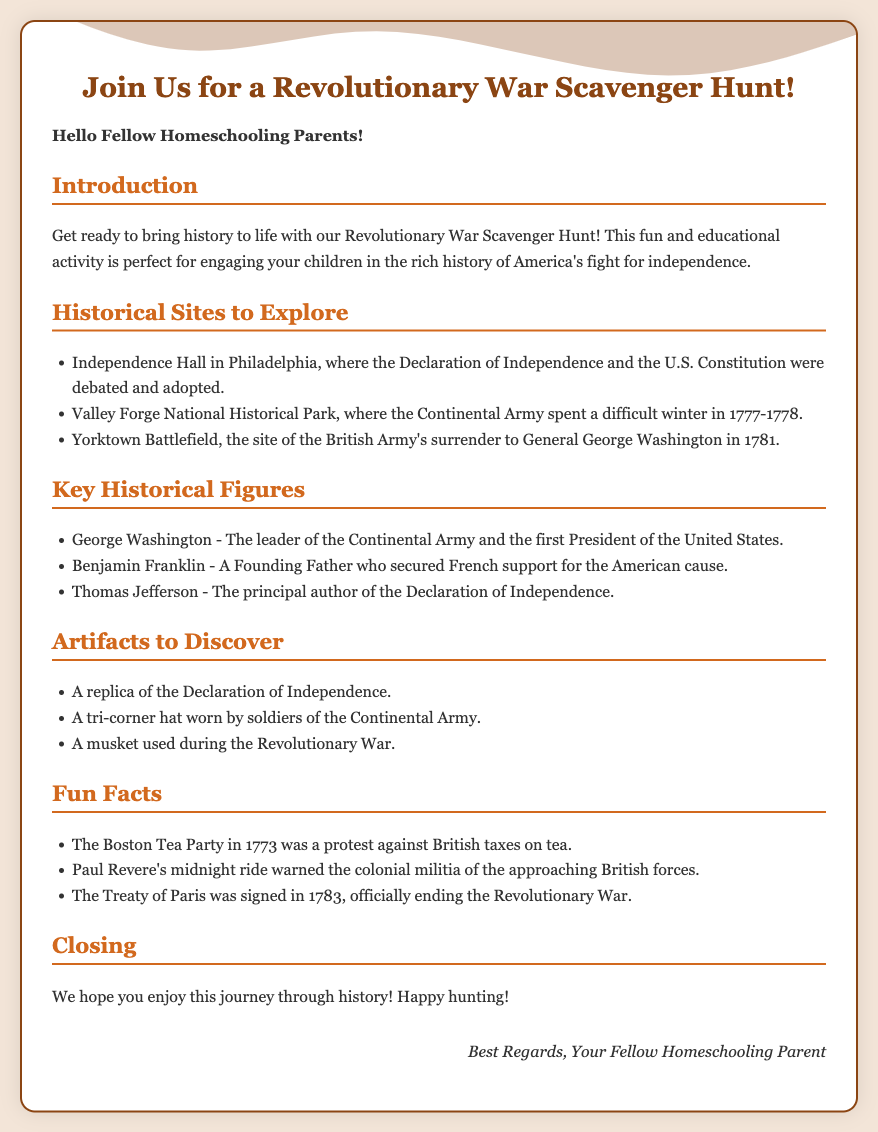What is the primary event discussed in the card? The card is about an engaging educational activity, specifically a scavenger hunt, related to the Revolutionary War.
Answer: Revolutionary War Scavenger Hunt What historical site is mentioned first in the scavenger hunt? The first historical site listed for exploration in the scavenger hunt is Independence Hall.
Answer: Independence Hall Who is the first key historical figure listed? The document outlines several important historical figures, with George Washington mentioned first.
Answer: George Washington What artifact is described as a representation of the Declaration of Independence? The document mentions a replica of the Declaration of Independence among artifacts to discover.
Answer: A replica of the Declaration of Independence What year did the Treaty of Paris officially end the Revolutionary War? The document states that the Treaty of Paris was signed in 1783, marking the end of the war.
Answer: 1783 Why is Benjamin Franklin significant according to the card? Benjamin Franklin is recognized for securing French support for the American cause during the Revolutionary War.
Answer: Secured French support What activity helps engage children in history according to the card? The greeting card promotes a scavenger hunt as an engaging activity to teach children about history.
Answer: Scavenger Hunt Who is the intended audience for this card? The card is specifically addressed to fellow homeschooling parents, suggesting that they are the primary audience.
Answer: Homeschooling parents What historical event took place during the Boston Tea Party? The Boston Tea Party was a protest against British taxes on tea.
Answer: A protest against British taxes on tea 